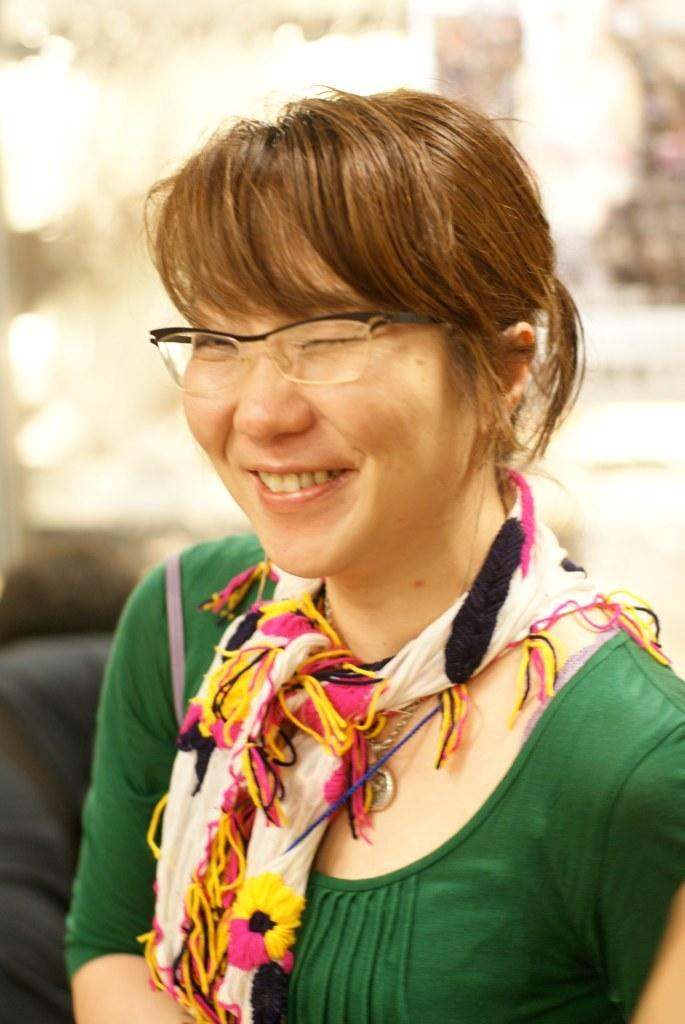Who is present in the image? There is a woman in the image. What is the woman's facial expression? The woman is smiling. Can you describe the object behind the woman? Unfortunately, the provided facts do not give enough information to describe the object behind the woman. What type of whistle is the woman using in the image? There is no whistle present in the image. 